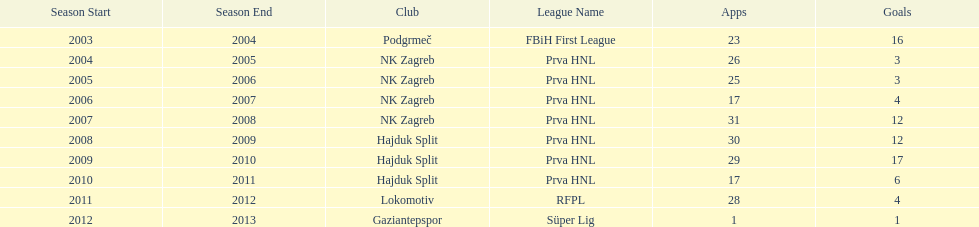Did ibricic score more or less goals in his 3 seasons with hajduk split when compared to his 4 seasons with nk zagreb? More. 